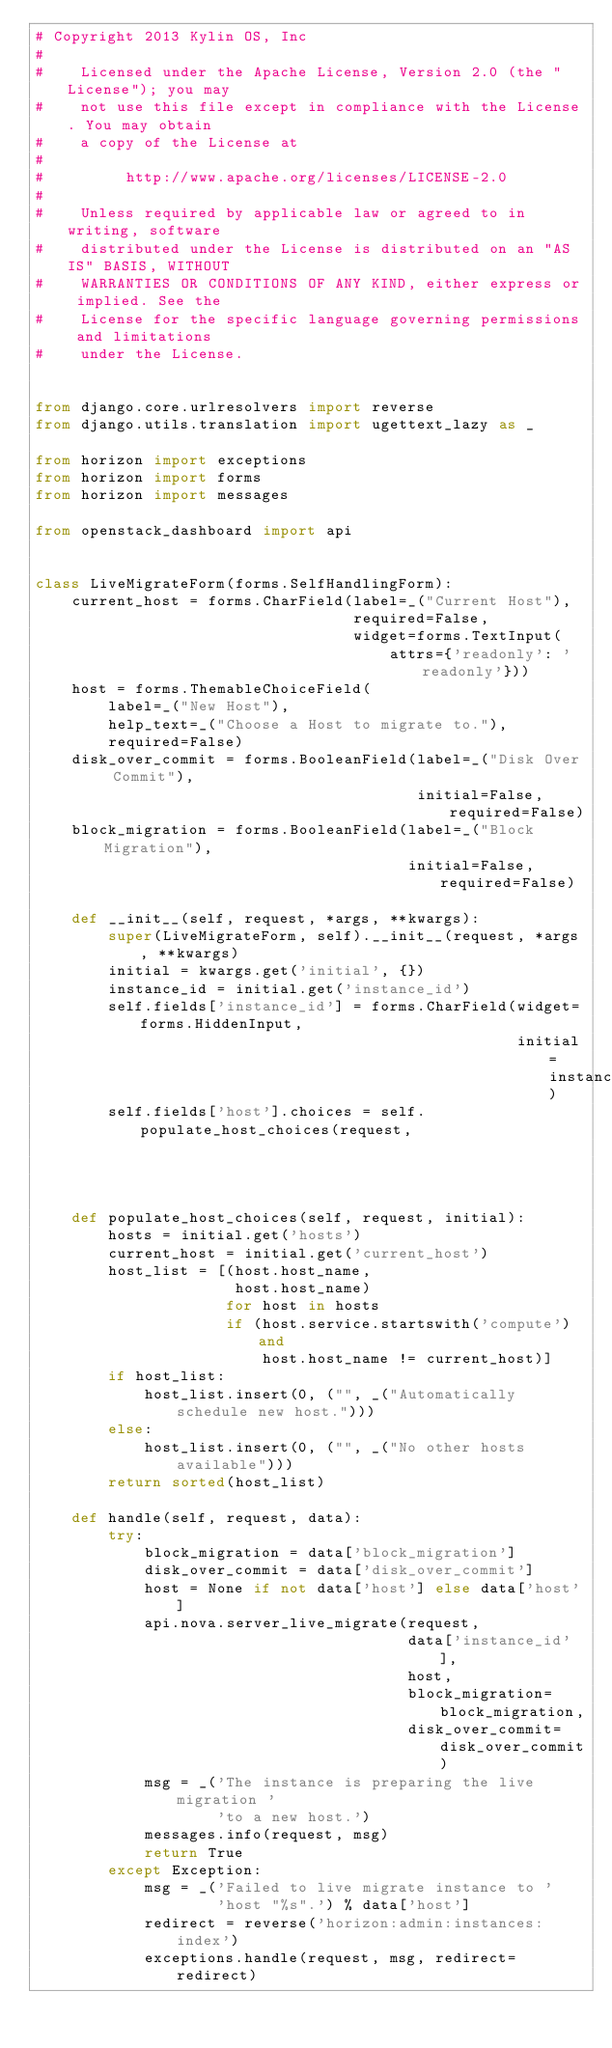Convert code to text. <code><loc_0><loc_0><loc_500><loc_500><_Python_># Copyright 2013 Kylin OS, Inc
#
#    Licensed under the Apache License, Version 2.0 (the "License"); you may
#    not use this file except in compliance with the License. You may obtain
#    a copy of the License at
#
#         http://www.apache.org/licenses/LICENSE-2.0
#
#    Unless required by applicable law or agreed to in writing, software
#    distributed under the License is distributed on an "AS IS" BASIS, WITHOUT
#    WARRANTIES OR CONDITIONS OF ANY KIND, either express or implied. See the
#    License for the specific language governing permissions and limitations
#    under the License.


from django.core.urlresolvers import reverse
from django.utils.translation import ugettext_lazy as _

from horizon import exceptions
from horizon import forms
from horizon import messages

from openstack_dashboard import api


class LiveMigrateForm(forms.SelfHandlingForm):
    current_host = forms.CharField(label=_("Current Host"),
                                   required=False,
                                   widget=forms.TextInput(
                                       attrs={'readonly': 'readonly'}))
    host = forms.ThemableChoiceField(
        label=_("New Host"),
        help_text=_("Choose a Host to migrate to."),
        required=False)
    disk_over_commit = forms.BooleanField(label=_("Disk Over Commit"),
                                          initial=False, required=False)
    block_migration = forms.BooleanField(label=_("Block Migration"),
                                         initial=False, required=False)

    def __init__(self, request, *args, **kwargs):
        super(LiveMigrateForm, self).__init__(request, *args, **kwargs)
        initial = kwargs.get('initial', {})
        instance_id = initial.get('instance_id')
        self.fields['instance_id'] = forms.CharField(widget=forms.HiddenInput,
                                                     initial=instance_id)
        self.fields['host'].choices = self.populate_host_choices(request,
                                                                 initial)

    def populate_host_choices(self, request, initial):
        hosts = initial.get('hosts')
        current_host = initial.get('current_host')
        host_list = [(host.host_name,
                      host.host_name)
                     for host in hosts
                     if (host.service.startswith('compute') and
                         host.host_name != current_host)]
        if host_list:
            host_list.insert(0, ("", _("Automatically schedule new host.")))
        else:
            host_list.insert(0, ("", _("No other hosts available")))
        return sorted(host_list)

    def handle(self, request, data):
        try:
            block_migration = data['block_migration']
            disk_over_commit = data['disk_over_commit']
            host = None if not data['host'] else data['host']
            api.nova.server_live_migrate(request,
                                         data['instance_id'],
                                         host,
                                         block_migration=block_migration,
                                         disk_over_commit=disk_over_commit)
            msg = _('The instance is preparing the live migration '
                    'to a new host.')
            messages.info(request, msg)
            return True
        except Exception:
            msg = _('Failed to live migrate instance to '
                    'host "%s".') % data['host']
            redirect = reverse('horizon:admin:instances:index')
            exceptions.handle(request, msg, redirect=redirect)
</code> 